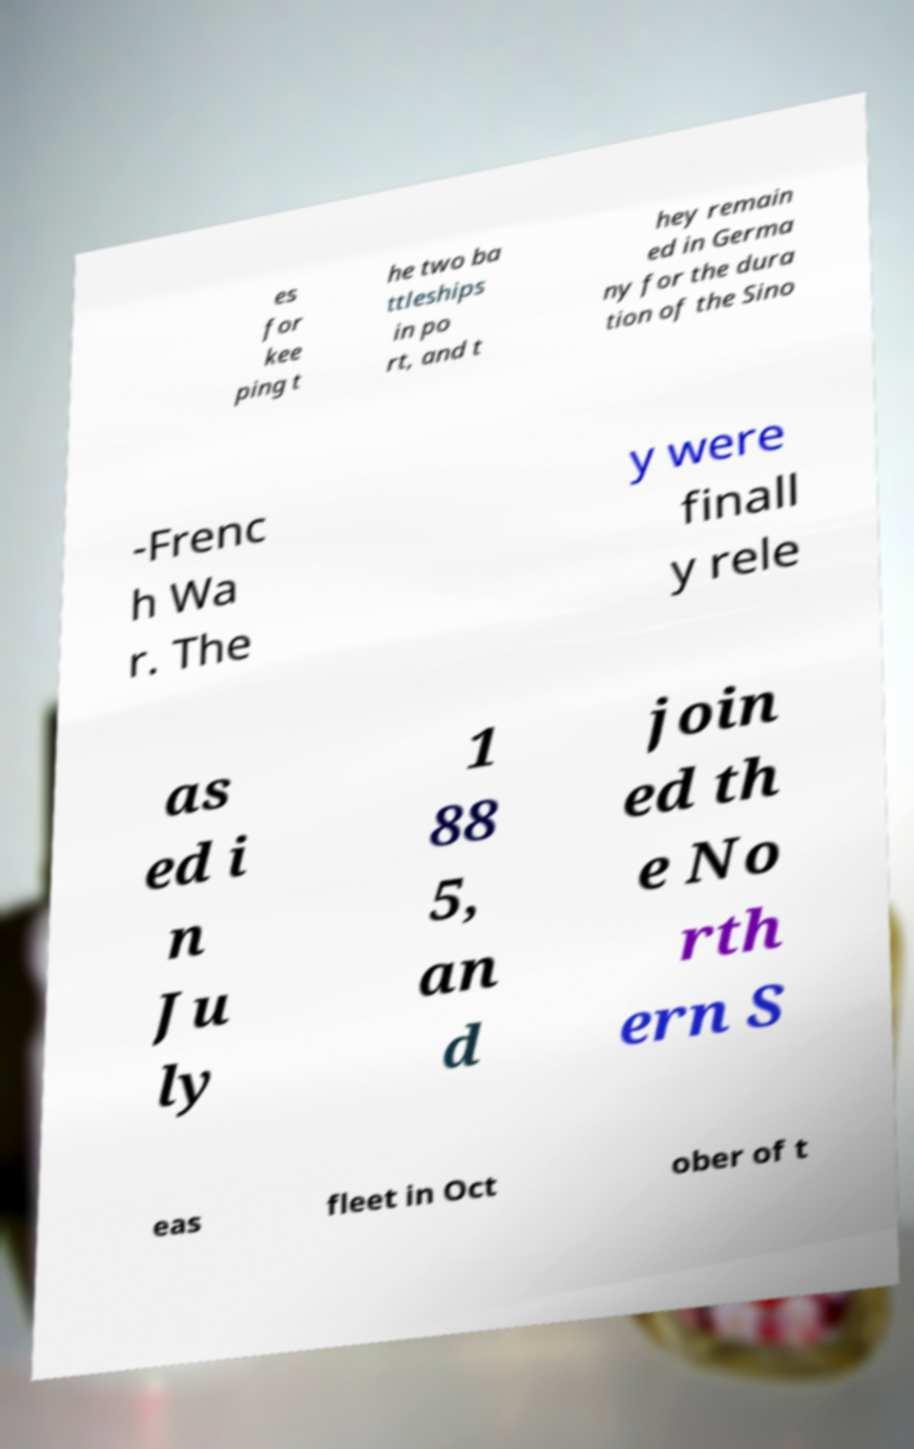Can you read and provide the text displayed in the image?This photo seems to have some interesting text. Can you extract and type it out for me? es for kee ping t he two ba ttleships in po rt, and t hey remain ed in Germa ny for the dura tion of the Sino -Frenc h Wa r. The y were finall y rele as ed i n Ju ly 1 88 5, an d join ed th e No rth ern S eas fleet in Oct ober of t 